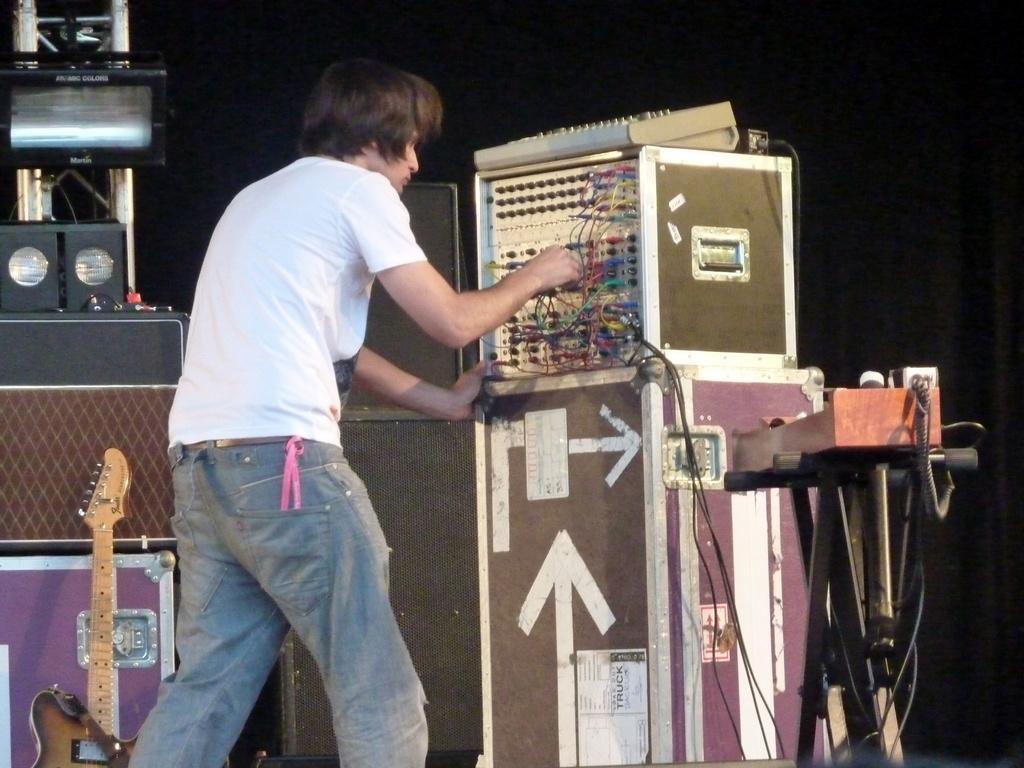Please provide a concise description of this image. In this image In the foreground I can see a person and there is a podium in the middle, on which there is a music control system, there is a stand beside the podium, on which there are some objects visible, on the left side there are speakers, light, guitar visible. 